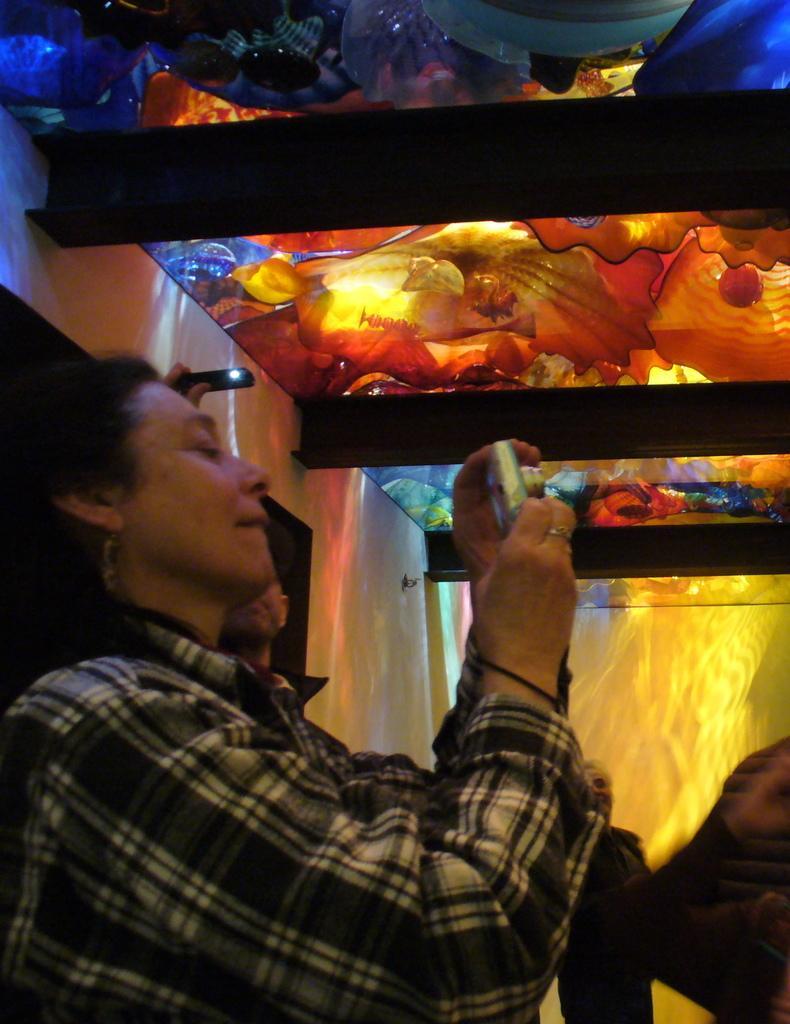Could you give a brief overview of what you see in this image? In this picture there is a lady who is standing on the left side of the image, by holding a camera in her hand and there is a colorful roof at the top side of the image. 